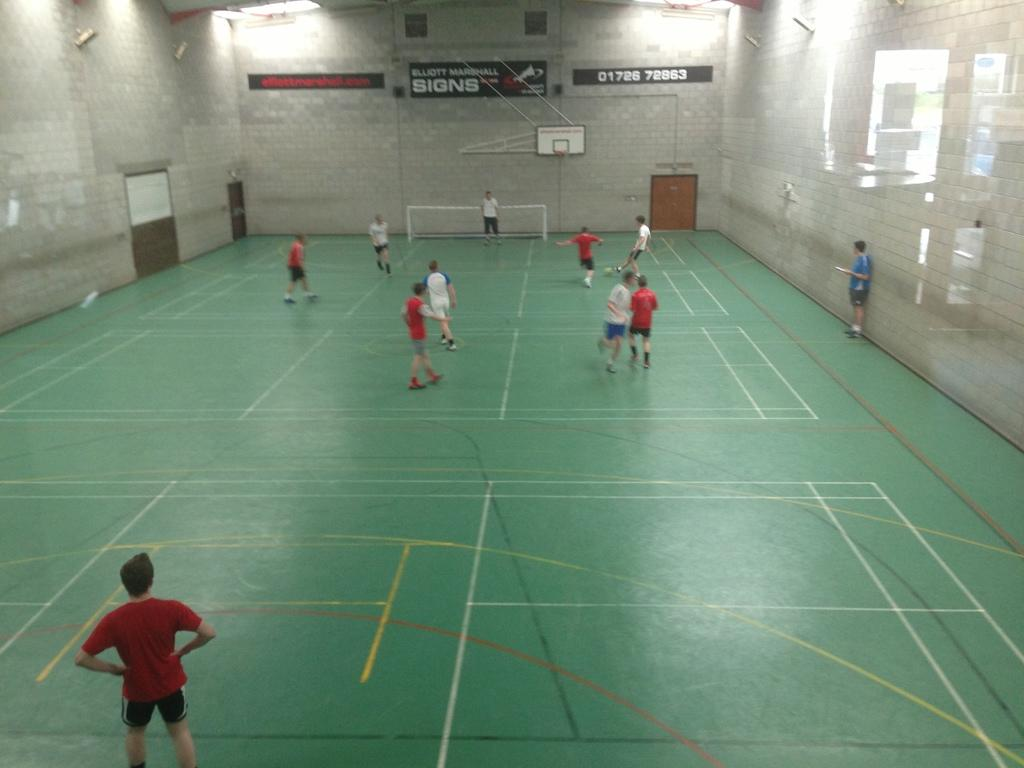<image>
Render a clear and concise summary of the photo. A gym with a sign on the back wall that says SIGNS. 